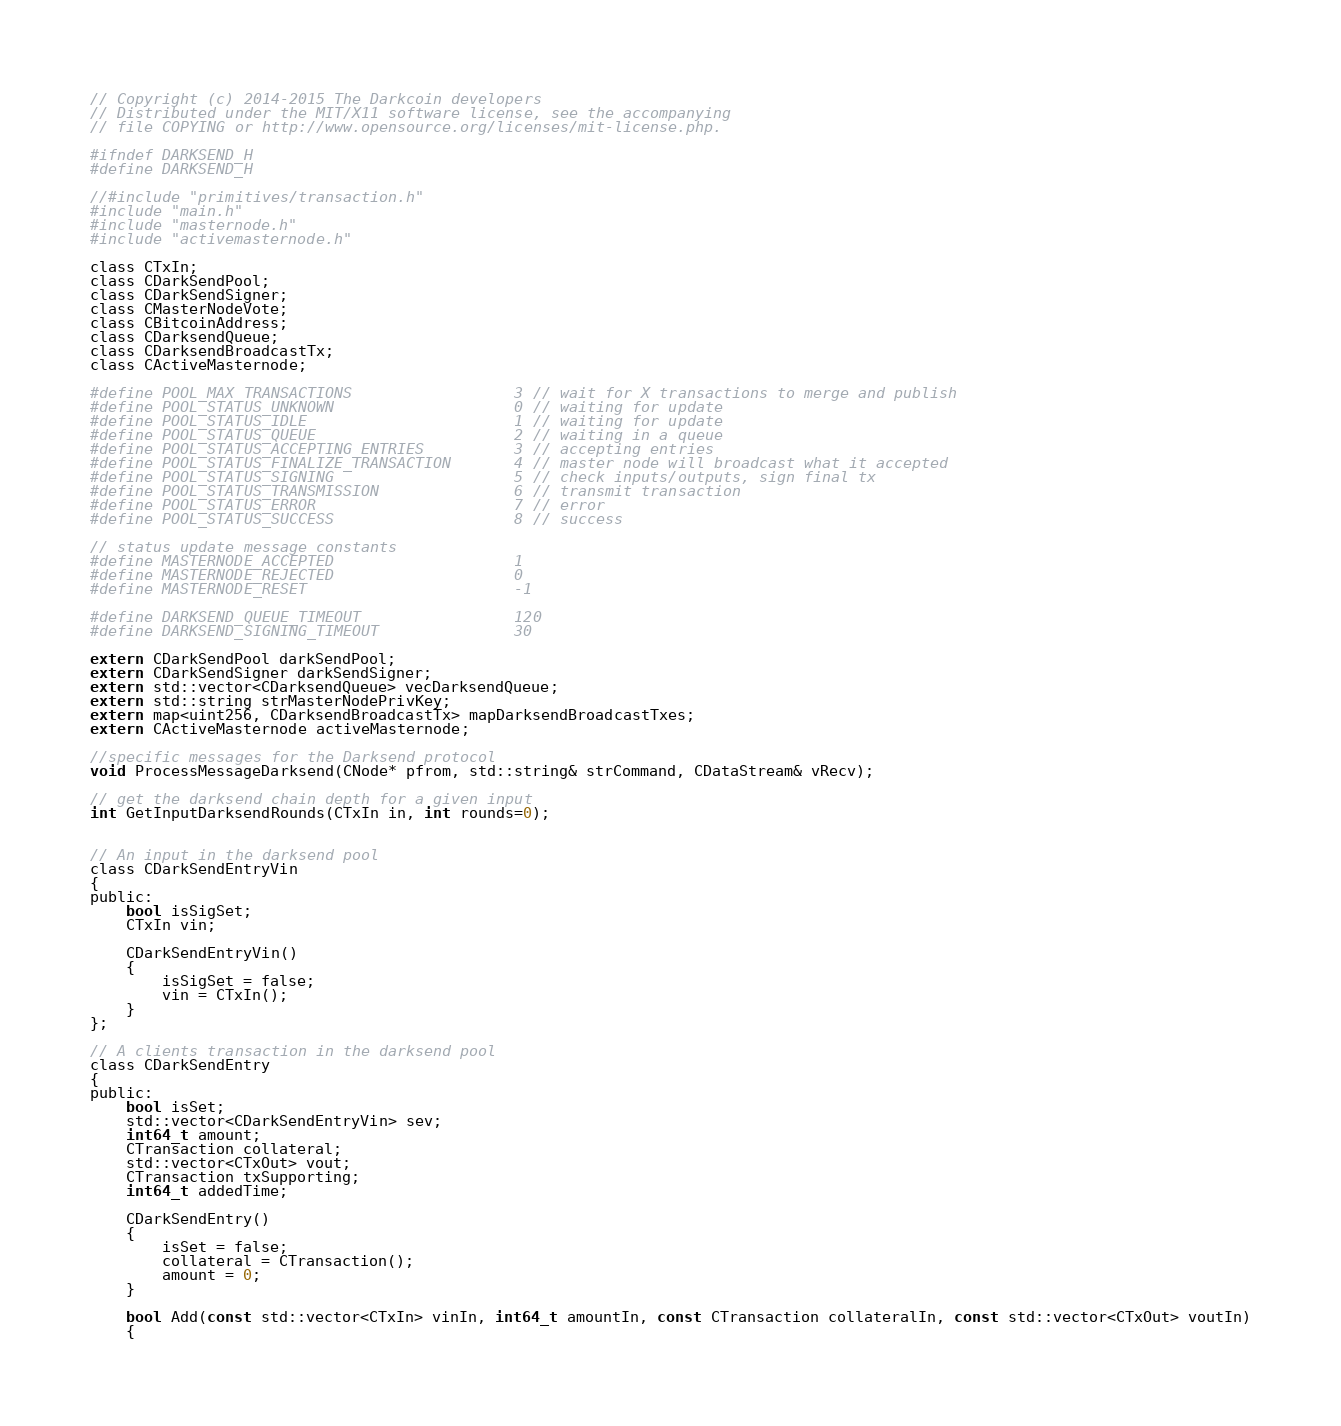Convert code to text. <code><loc_0><loc_0><loc_500><loc_500><_C_>// Copyright (c) 2014-2015 The Darkcoin developers
// Distributed under the MIT/X11 software license, see the accompanying
// file COPYING or http://www.opensource.org/licenses/mit-license.php.

#ifndef DARKSEND_H
#define DARKSEND_H

//#include "primitives/transaction.h"
#include "main.h"
#include "masternode.h"
#include "activemasternode.h"

class CTxIn;
class CDarkSendPool;
class CDarkSendSigner;
class CMasterNodeVote;
class CBitcoinAddress;
class CDarksendQueue;
class CDarksendBroadcastTx;
class CActiveMasternode;

#define POOL_MAX_TRANSACTIONS                  3 // wait for X transactions to merge and publish
#define POOL_STATUS_UNKNOWN                    0 // waiting for update
#define POOL_STATUS_IDLE                       1 // waiting for update
#define POOL_STATUS_QUEUE                      2 // waiting in a queue
#define POOL_STATUS_ACCEPTING_ENTRIES          3 // accepting entries
#define POOL_STATUS_FINALIZE_TRANSACTION       4 // master node will broadcast what it accepted
#define POOL_STATUS_SIGNING                    5 // check inputs/outputs, sign final tx
#define POOL_STATUS_TRANSMISSION               6 // transmit transaction
#define POOL_STATUS_ERROR                      7 // error
#define POOL_STATUS_SUCCESS                    8 // success

// status update message constants
#define MASTERNODE_ACCEPTED                    1
#define MASTERNODE_REJECTED                    0
#define MASTERNODE_RESET                       -1

#define DARKSEND_QUEUE_TIMEOUT                 120
#define DARKSEND_SIGNING_TIMEOUT               30

extern CDarkSendPool darkSendPool;
extern CDarkSendSigner darkSendSigner;
extern std::vector<CDarksendQueue> vecDarksendQueue;
extern std::string strMasterNodePrivKey;
extern map<uint256, CDarksendBroadcastTx> mapDarksendBroadcastTxes;
extern CActiveMasternode activeMasternode;

//specific messages for the Darksend protocol
void ProcessMessageDarksend(CNode* pfrom, std::string& strCommand, CDataStream& vRecv);

// get the darksend chain depth for a given input
int GetInputDarksendRounds(CTxIn in, int rounds=0);


// An input in the darksend pool
class CDarkSendEntryVin
{
public:
    bool isSigSet;
    CTxIn vin;

    CDarkSendEntryVin()
    {
        isSigSet = false;
        vin = CTxIn();
    }
};

// A clients transaction in the darksend pool
class CDarkSendEntry
{
public:
    bool isSet;
    std::vector<CDarkSendEntryVin> sev;
    int64_t amount;
    CTransaction collateral;
    std::vector<CTxOut> vout;
    CTransaction txSupporting;
    int64_t addedTime;

    CDarkSendEntry()
    {
        isSet = false;
        collateral = CTransaction();
        amount = 0;
    }

    bool Add(const std::vector<CTxIn> vinIn, int64_t amountIn, const CTransaction collateralIn, const std::vector<CTxOut> voutIn)
    {</code> 